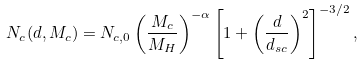Convert formula to latex. <formula><loc_0><loc_0><loc_500><loc_500>N _ { c } ( d , M _ { c } ) = N _ { c , 0 } \left ( \frac { M _ { c } } { M _ { H } } \right ) ^ { - \alpha } \left [ 1 + \left ( \frac { d } { d _ { s c } } \right ) ^ { 2 } \right ] ^ { - 3 / 2 } ,</formula> 